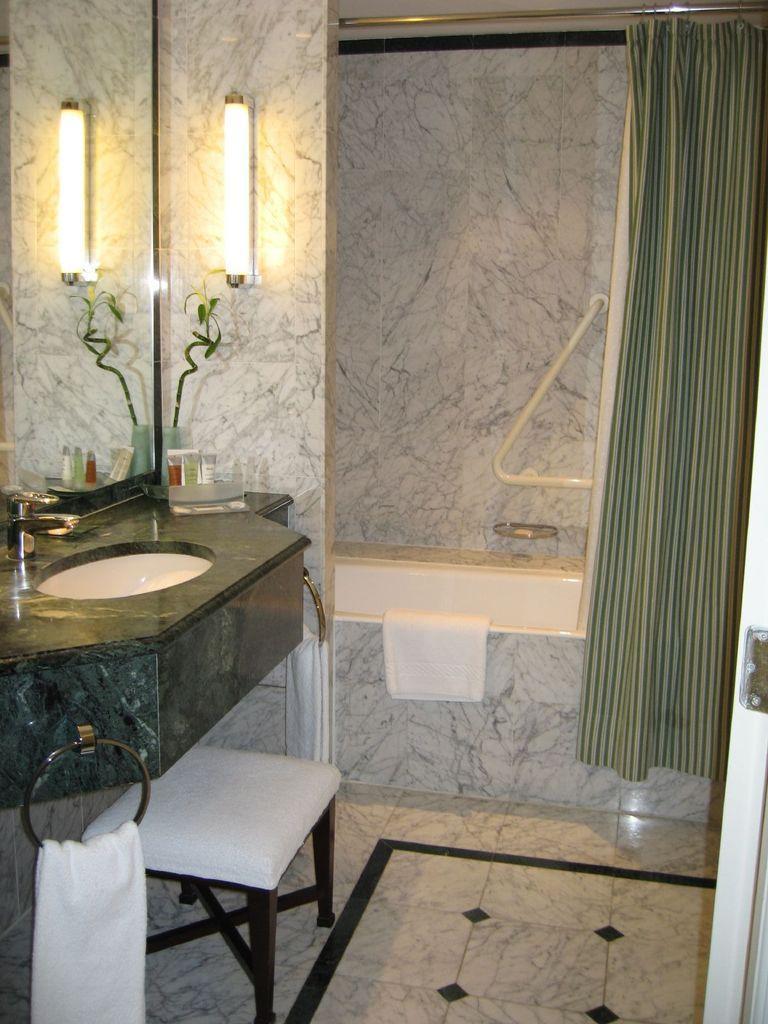How would you summarize this image in a sentence or two? In this image I can see the sink, a tap, the mirror, a plant, the light, the wall which is white and black in color, a towel which is white in color, the bath tub which is white in color and a towel on the tub and the curtain which is green in color. To the right side of the image I can see the door which is white in color. 